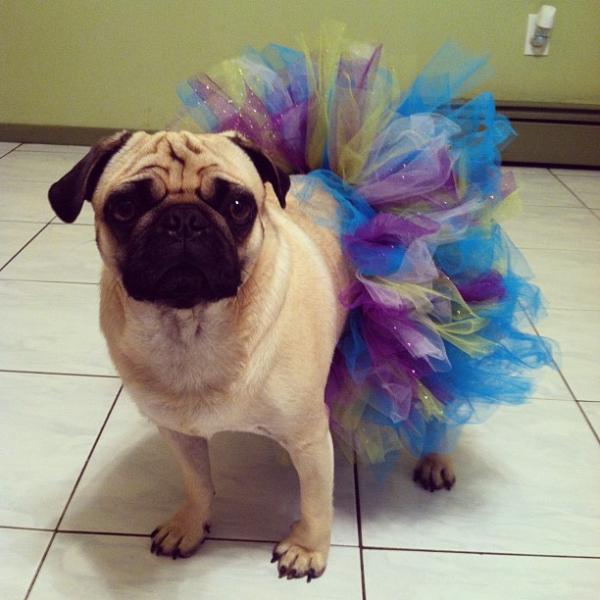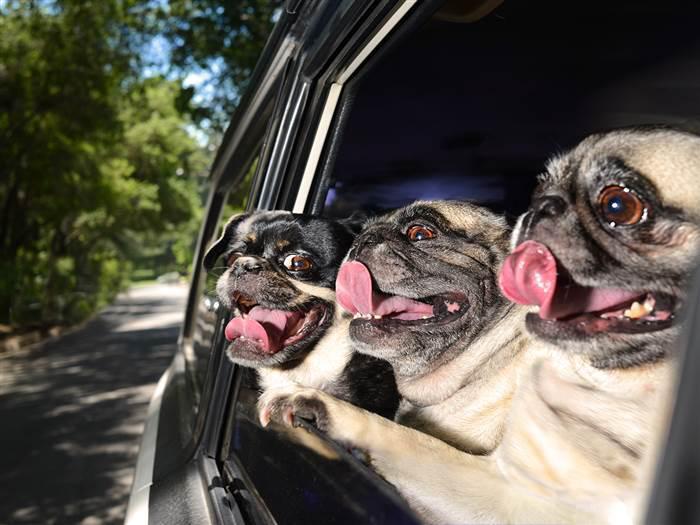The first image is the image on the left, the second image is the image on the right. For the images displayed, is the sentence "One image shows a horizontal row of pug dogs that are not in costume." factually correct? Answer yes or no. Yes. The first image is the image on the left, the second image is the image on the right. Assess this claim about the two images: "Both dogs are being dressed in human like attire.". Correct or not? Answer yes or no. No. 